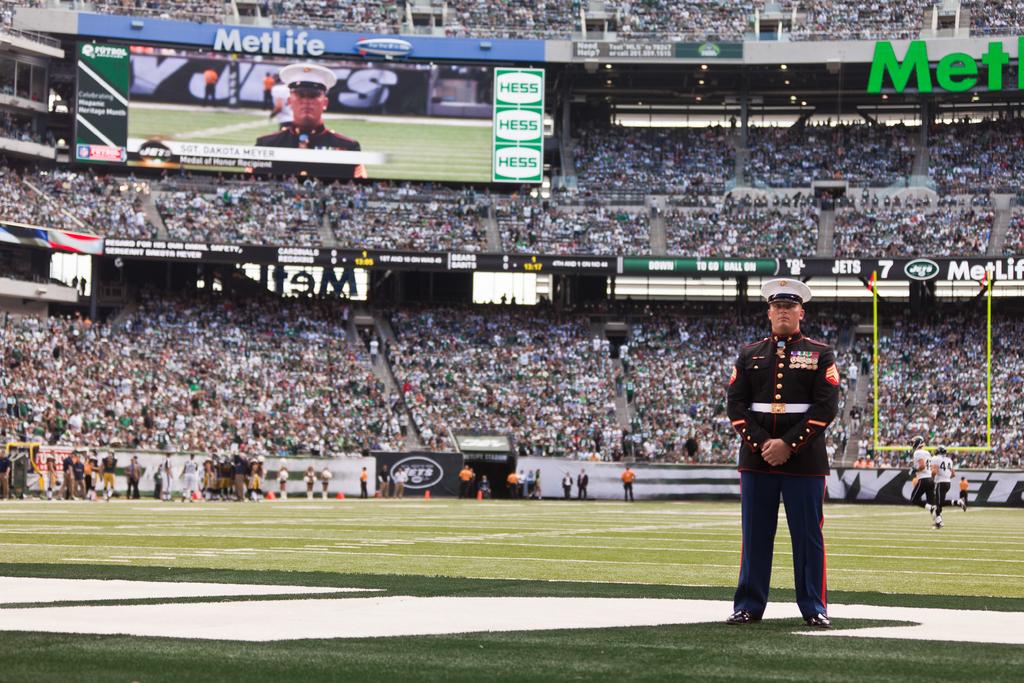What is in green on the top right?
Ensure brevity in your answer.  Met. 